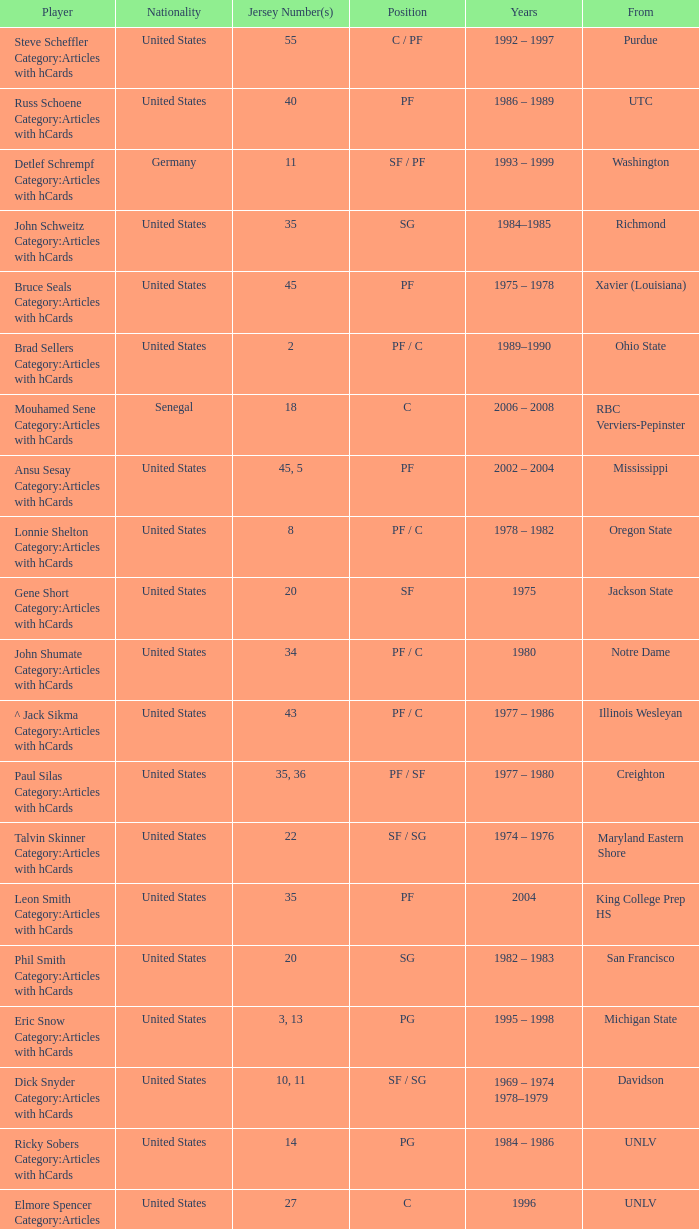What nationality is the player from Oregon State? United States. 